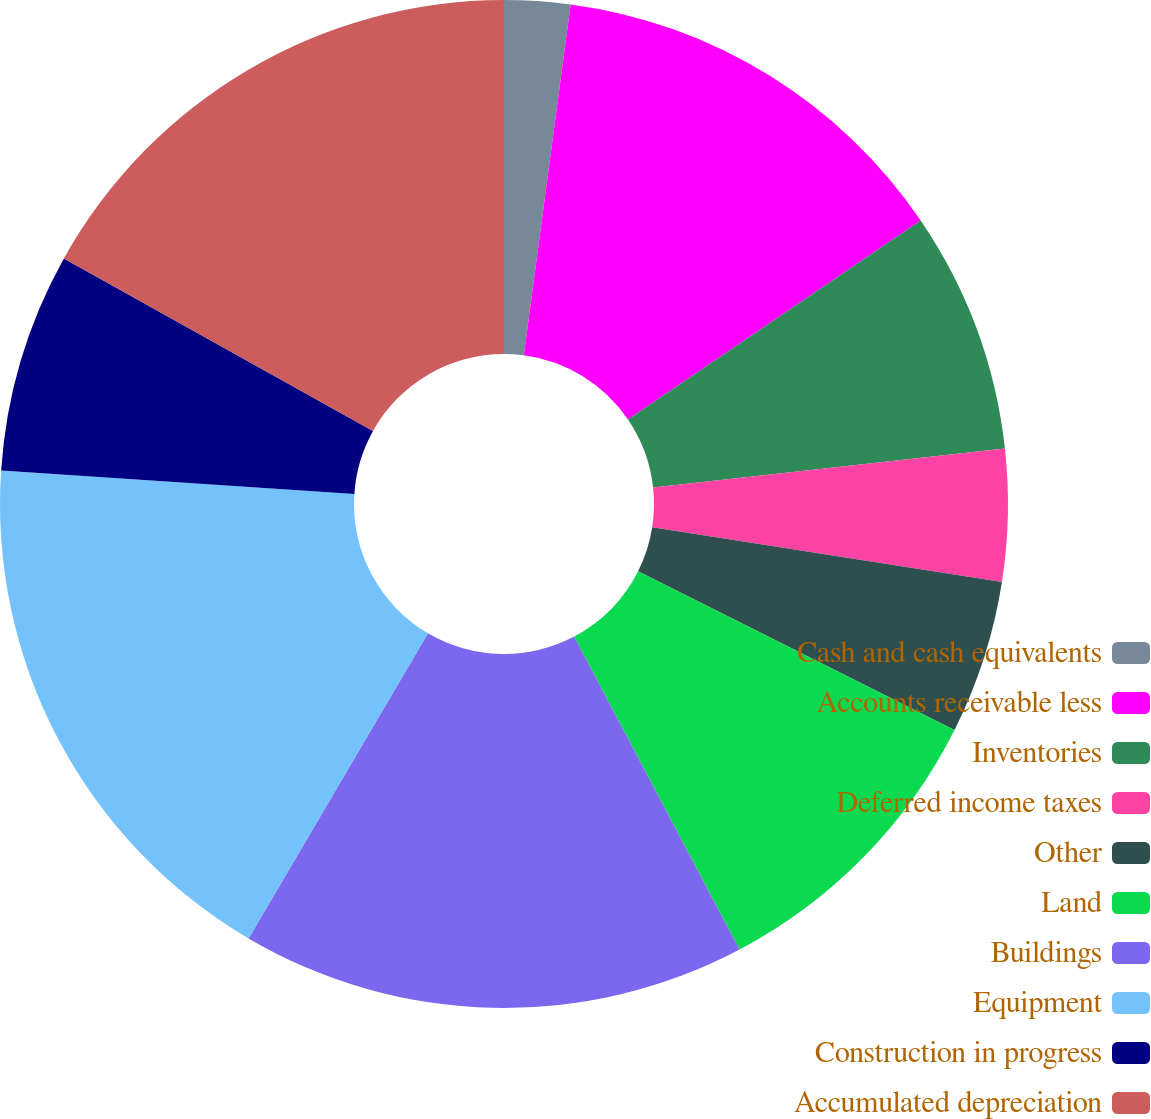Convert chart. <chart><loc_0><loc_0><loc_500><loc_500><pie_chart><fcel>Cash and cash equivalents<fcel>Accounts receivable less<fcel>Inventories<fcel>Deferred income taxes<fcel>Other<fcel>Land<fcel>Buildings<fcel>Equipment<fcel>Construction in progress<fcel>Accumulated depreciation<nl><fcel>2.11%<fcel>13.38%<fcel>7.75%<fcel>4.23%<fcel>4.93%<fcel>9.86%<fcel>16.2%<fcel>17.6%<fcel>7.04%<fcel>16.9%<nl></chart> 